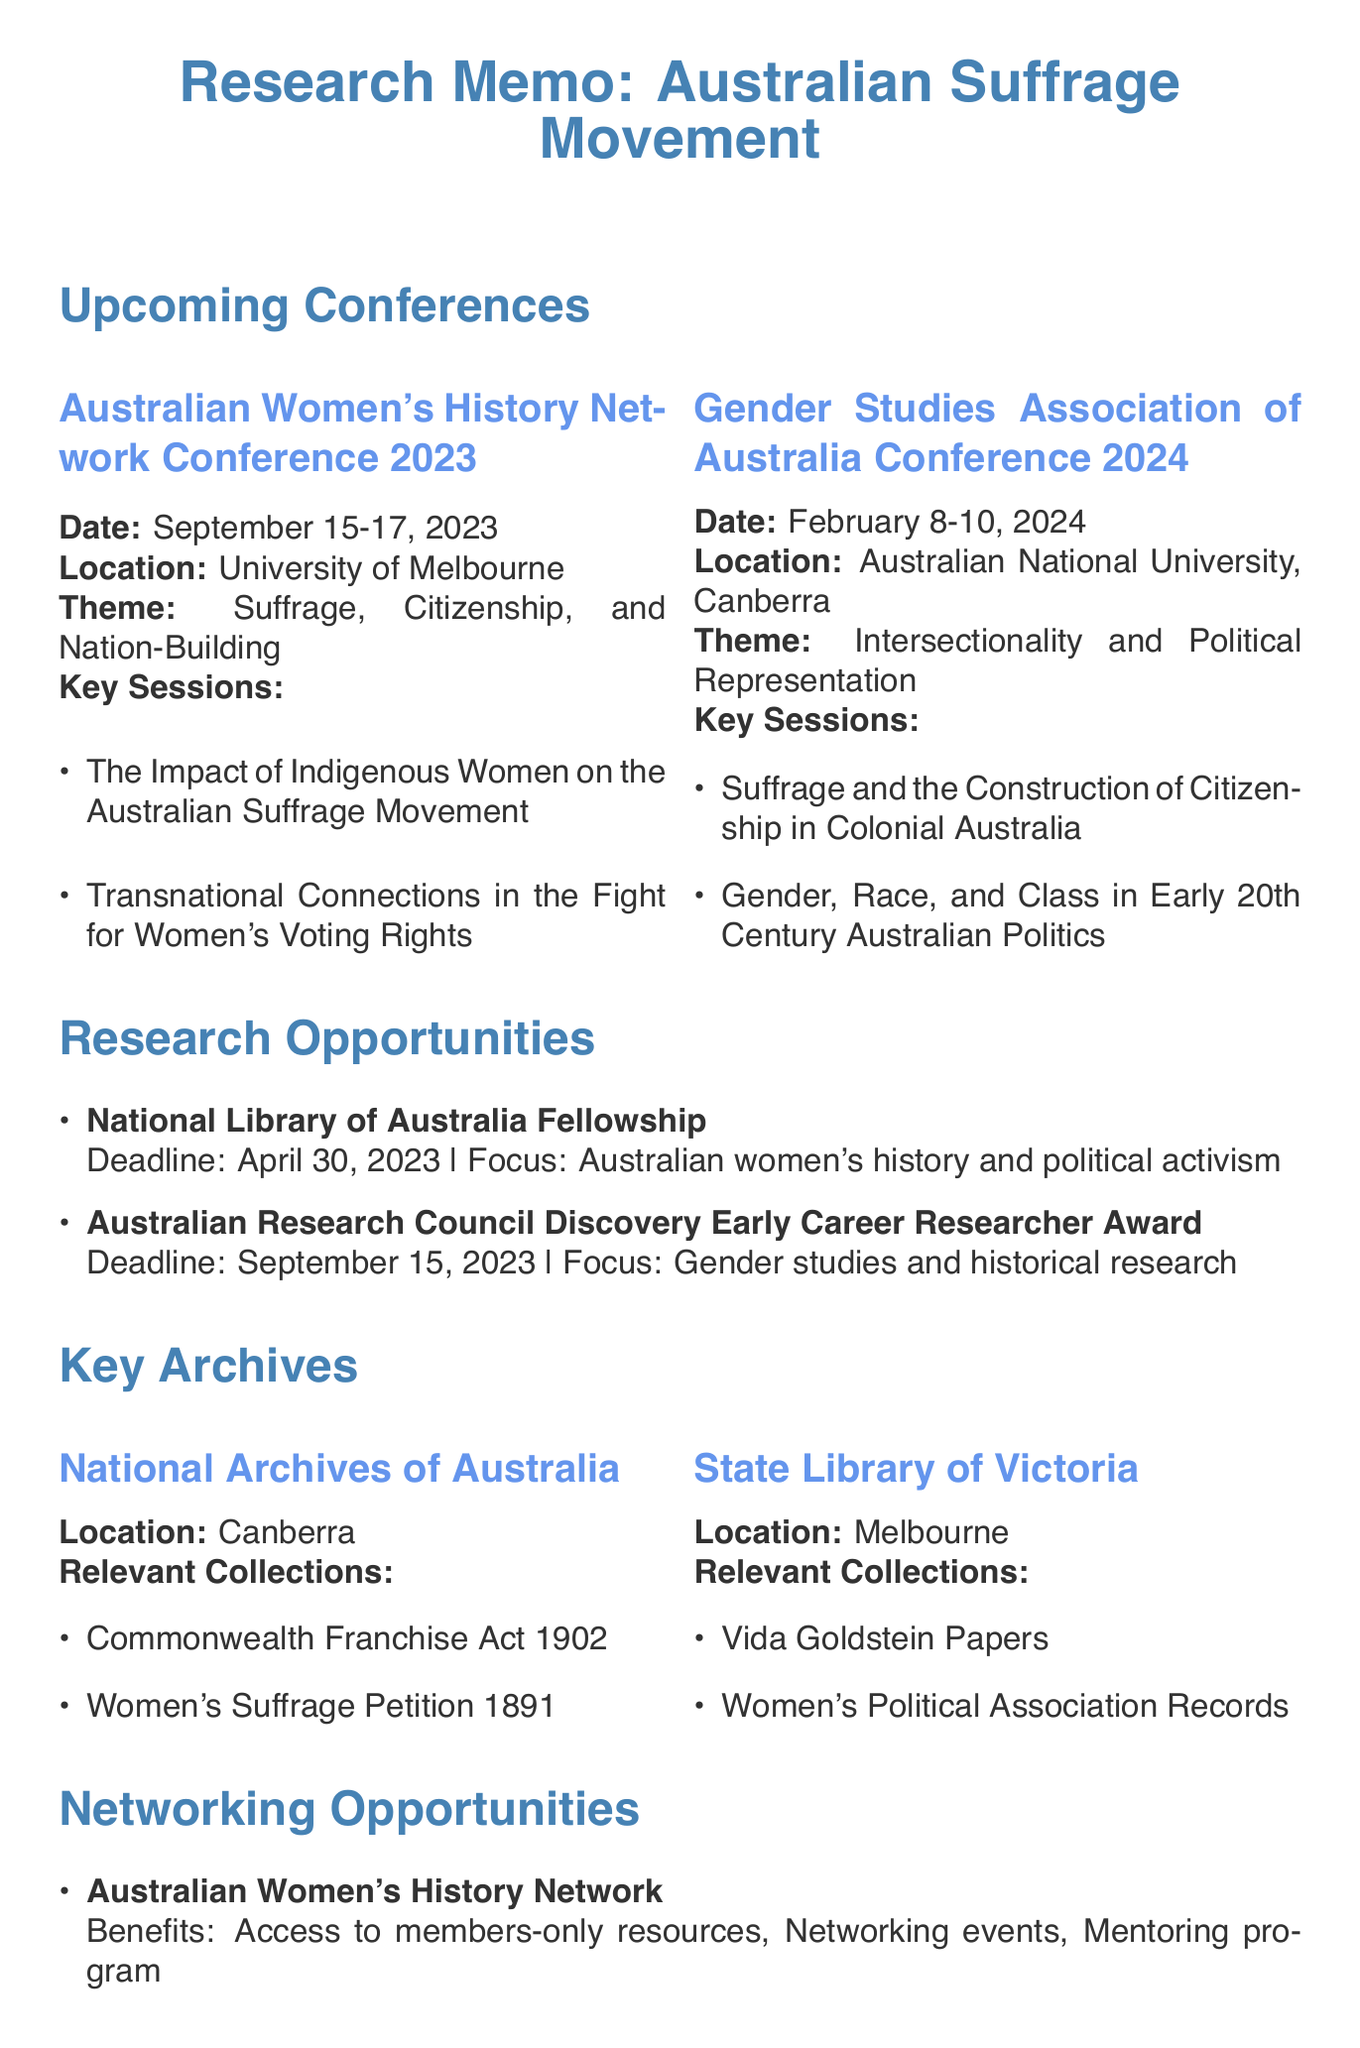What is the date of the Australian Women's History Network Conference 2023? The document provides the date as September 15-17, 2023.
Answer: September 15-17, 2023 Who is a keynote speaker at the Gender Studies Association of Australia Conference 2024? The document lists Professor Marilyn Lake as a keynote speaker for this conference.
Answer: Professor Marilyn Lake What is the theme of the Australian Historical Association Conference 2023? According to the document, the theme is "Unfinished Business: Histories of Gender and Sexuality."
Answer: Unfinished Business: Histories of Gender and Sexuality What is the funding amount for the Australian Research Council Discovery Early Career Researcher Award? The document states that the funding is up to AUD 425,000.
Answer: Up to AUD 425,000 Which archive holds the Women's Suffrage Petition 1891? The National Archives of Australia houses the Women's Suffrage Petition 1891, according to the document.
Answer: National Archives of Australia How many relevant sessions are listed for the Australian Women's History Network Conference 2023? The document provides three relevant sessions for this conference.
Answer: Three What is one of the membership benefits of the Australian Women's History Network? The document lists access to members-only resources as a benefit of membership.
Answer: Access to members-only resources When is the deadline for the National Library of Australia Fellowship? The deadline stated in the document is April 30, 2023.
Answer: April 30, 2023 What location hosts the Gender Studies Association of Australia Conference 2024? The document specifies that it will be held at the Australian National University in Canberra.
Answer: Australian National University, Canberra 